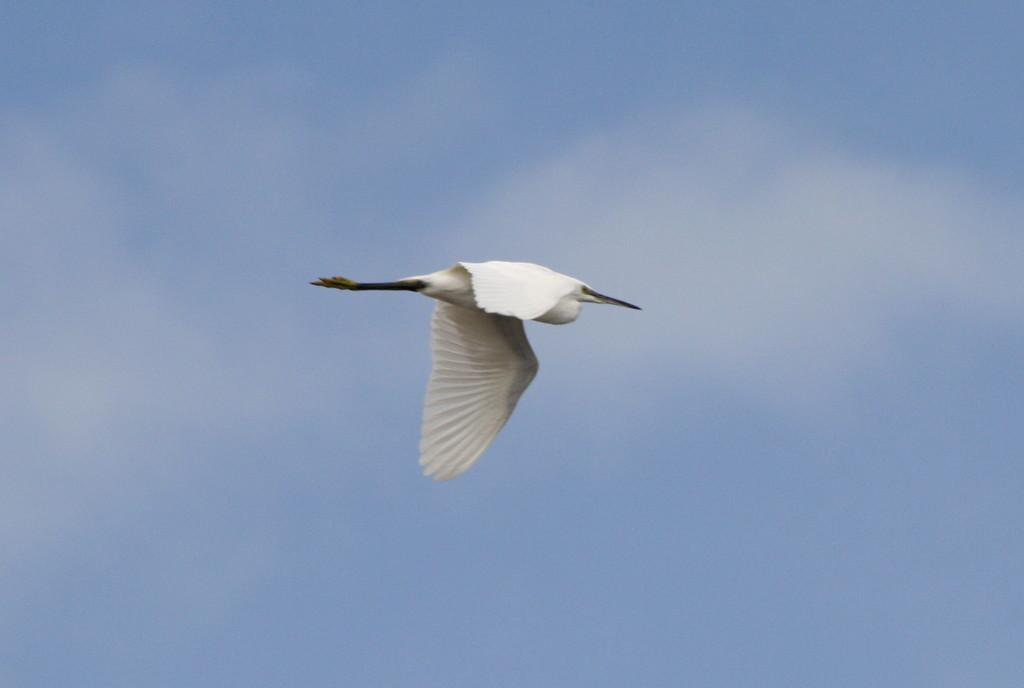What type of animal can be seen in the image? There is a white bird in the image. What is the bird doing in the image? The bird is flying in the sky. What type of cloth is being used to fly the bird in the image? There is no cloth being used to fly the bird in the image; the bird is flying on its own. 